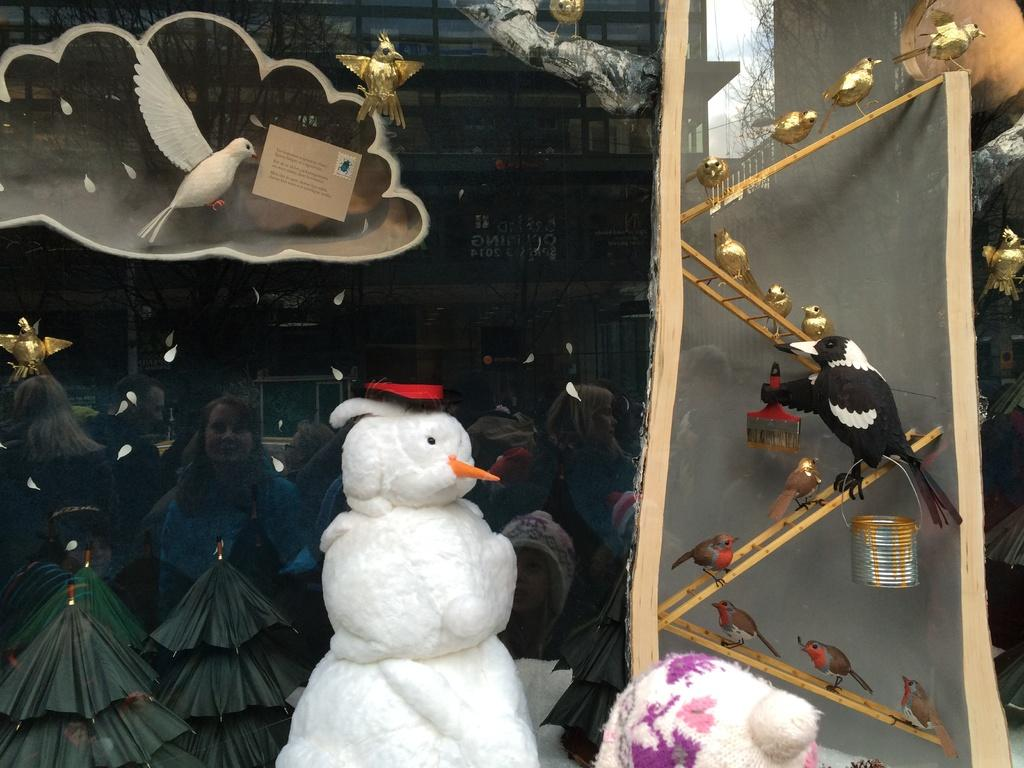What is the main subject of the image? There is a snowman in the image. What other elements are present in the image? There is a depiction of birds in the image, and one of the birds is holding a paintbrush and a small can. Are there any people visible in the image? Yes, there are people visible in the image. How many frogs are sitting on the snowman's hat in the image? There are no frogs present in the image; it features a snowman, birds, and people. What type of beetle can be seen crawling on the snowman's nose in the image? There is no beetle present on the snowman's nose in the image. 